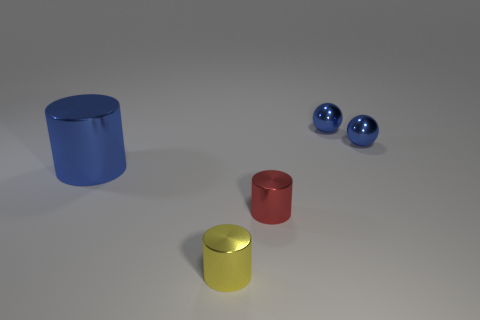Subtract all small metallic cylinders. How many cylinders are left? 1 Subtract 1 cylinders. How many cylinders are left? 2 Subtract all cylinders. How many objects are left? 2 Subtract all yellow cylinders. Subtract all cyan cubes. How many cylinders are left? 2 Subtract all purple balls. How many red cylinders are left? 1 Subtract all tiny shiny things. Subtract all tiny red metal objects. How many objects are left? 0 Add 1 big shiny objects. How many big shiny objects are left? 2 Add 3 tiny things. How many tiny things exist? 7 Add 2 small yellow cylinders. How many objects exist? 7 Subtract all yellow cylinders. How many cylinders are left? 2 